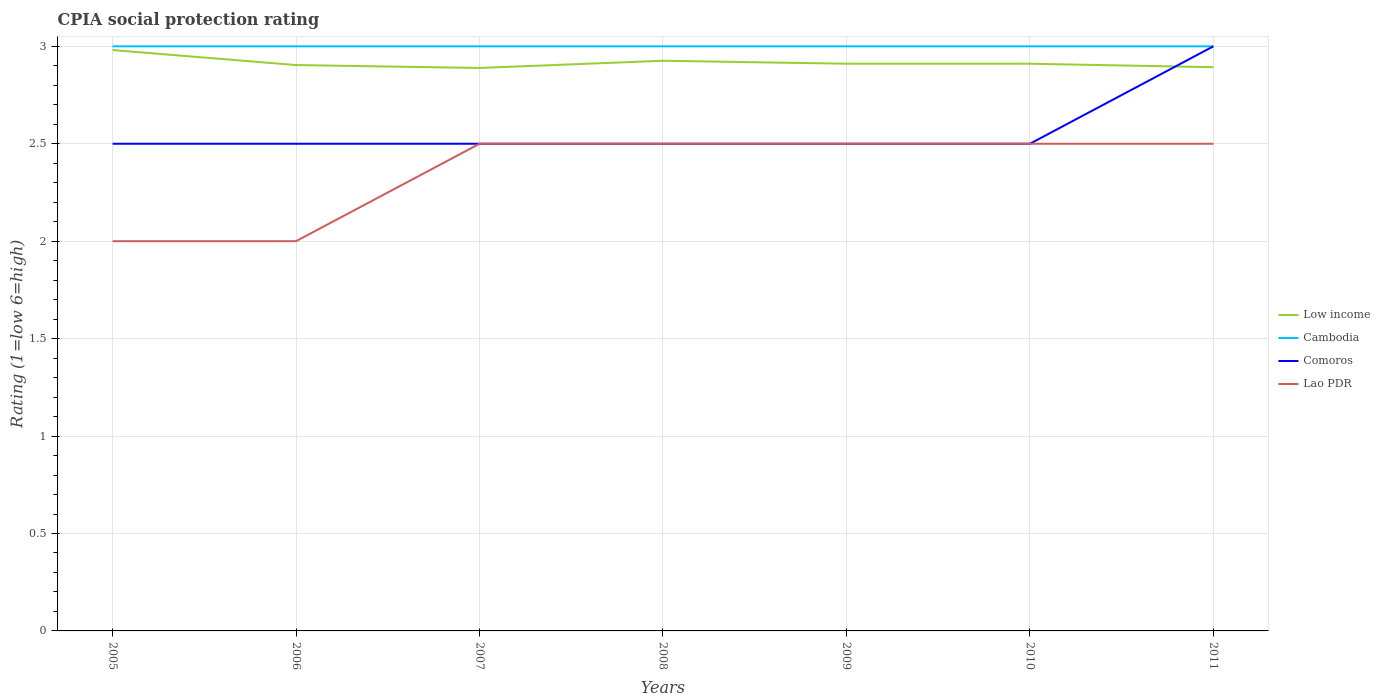Across all years, what is the maximum CPIA rating in Lao PDR?
Ensure brevity in your answer.  2. What is the total CPIA rating in Low income in the graph?
Your response must be concise. -0.04. What is the difference between the highest and the second highest CPIA rating in Lao PDR?
Your response must be concise. 0.5. What is the difference between the highest and the lowest CPIA rating in Cambodia?
Your answer should be compact. 0. What is the title of the graph?
Provide a short and direct response. CPIA social protection rating. What is the Rating (1=low 6=high) of Low income in 2005?
Make the answer very short. 2.98. What is the Rating (1=low 6=high) in Comoros in 2005?
Provide a short and direct response. 2.5. What is the Rating (1=low 6=high) of Lao PDR in 2005?
Give a very brief answer. 2. What is the Rating (1=low 6=high) of Low income in 2006?
Provide a succinct answer. 2.9. What is the Rating (1=low 6=high) in Cambodia in 2006?
Offer a very short reply. 3. What is the Rating (1=low 6=high) in Comoros in 2006?
Your response must be concise. 2.5. What is the Rating (1=low 6=high) in Low income in 2007?
Make the answer very short. 2.89. What is the Rating (1=low 6=high) of Cambodia in 2007?
Ensure brevity in your answer.  3. What is the Rating (1=low 6=high) in Low income in 2008?
Offer a terse response. 2.93. What is the Rating (1=low 6=high) in Comoros in 2008?
Offer a very short reply. 2.5. What is the Rating (1=low 6=high) in Low income in 2009?
Offer a very short reply. 2.91. What is the Rating (1=low 6=high) in Comoros in 2009?
Your answer should be compact. 2.5. What is the Rating (1=low 6=high) in Low income in 2010?
Give a very brief answer. 2.91. What is the Rating (1=low 6=high) of Cambodia in 2010?
Provide a short and direct response. 3. What is the Rating (1=low 6=high) of Comoros in 2010?
Your answer should be very brief. 2.5. What is the Rating (1=low 6=high) in Lao PDR in 2010?
Your answer should be compact. 2.5. What is the Rating (1=low 6=high) of Low income in 2011?
Provide a succinct answer. 2.89. What is the Rating (1=low 6=high) of Comoros in 2011?
Ensure brevity in your answer.  3. Across all years, what is the maximum Rating (1=low 6=high) of Low income?
Your answer should be compact. 2.98. Across all years, what is the maximum Rating (1=low 6=high) of Cambodia?
Ensure brevity in your answer.  3. Across all years, what is the maximum Rating (1=low 6=high) of Comoros?
Offer a terse response. 3. Across all years, what is the maximum Rating (1=low 6=high) of Lao PDR?
Your response must be concise. 2.5. Across all years, what is the minimum Rating (1=low 6=high) of Low income?
Keep it short and to the point. 2.89. Across all years, what is the minimum Rating (1=low 6=high) of Cambodia?
Ensure brevity in your answer.  3. Across all years, what is the minimum Rating (1=low 6=high) of Comoros?
Offer a very short reply. 2.5. What is the total Rating (1=low 6=high) of Low income in the graph?
Give a very brief answer. 20.41. What is the total Rating (1=low 6=high) in Cambodia in the graph?
Give a very brief answer. 21. What is the total Rating (1=low 6=high) in Comoros in the graph?
Offer a very short reply. 18. What is the difference between the Rating (1=low 6=high) of Low income in 2005 and that in 2006?
Make the answer very short. 0.08. What is the difference between the Rating (1=low 6=high) of Cambodia in 2005 and that in 2006?
Your response must be concise. 0. What is the difference between the Rating (1=low 6=high) in Comoros in 2005 and that in 2006?
Give a very brief answer. 0. What is the difference between the Rating (1=low 6=high) of Lao PDR in 2005 and that in 2006?
Offer a terse response. 0. What is the difference between the Rating (1=low 6=high) of Low income in 2005 and that in 2007?
Give a very brief answer. 0.09. What is the difference between the Rating (1=low 6=high) of Cambodia in 2005 and that in 2007?
Offer a terse response. 0. What is the difference between the Rating (1=low 6=high) in Low income in 2005 and that in 2008?
Provide a short and direct response. 0.05. What is the difference between the Rating (1=low 6=high) of Cambodia in 2005 and that in 2008?
Make the answer very short. 0. What is the difference between the Rating (1=low 6=high) in Comoros in 2005 and that in 2008?
Provide a short and direct response. 0. What is the difference between the Rating (1=low 6=high) of Low income in 2005 and that in 2009?
Keep it short and to the point. 0.07. What is the difference between the Rating (1=low 6=high) in Cambodia in 2005 and that in 2009?
Keep it short and to the point. 0. What is the difference between the Rating (1=low 6=high) of Lao PDR in 2005 and that in 2009?
Your answer should be compact. -0.5. What is the difference between the Rating (1=low 6=high) in Low income in 2005 and that in 2010?
Provide a succinct answer. 0.07. What is the difference between the Rating (1=low 6=high) of Comoros in 2005 and that in 2010?
Provide a succinct answer. 0. What is the difference between the Rating (1=low 6=high) of Lao PDR in 2005 and that in 2010?
Provide a succinct answer. -0.5. What is the difference between the Rating (1=low 6=high) of Low income in 2005 and that in 2011?
Give a very brief answer. 0.09. What is the difference between the Rating (1=low 6=high) of Cambodia in 2005 and that in 2011?
Offer a very short reply. 0. What is the difference between the Rating (1=low 6=high) of Comoros in 2005 and that in 2011?
Make the answer very short. -0.5. What is the difference between the Rating (1=low 6=high) of Lao PDR in 2005 and that in 2011?
Offer a terse response. -0.5. What is the difference between the Rating (1=low 6=high) of Low income in 2006 and that in 2007?
Your response must be concise. 0.01. What is the difference between the Rating (1=low 6=high) of Comoros in 2006 and that in 2007?
Your answer should be very brief. 0. What is the difference between the Rating (1=low 6=high) in Lao PDR in 2006 and that in 2007?
Your answer should be very brief. -0.5. What is the difference between the Rating (1=low 6=high) in Low income in 2006 and that in 2008?
Provide a short and direct response. -0.02. What is the difference between the Rating (1=low 6=high) in Lao PDR in 2006 and that in 2008?
Offer a terse response. -0.5. What is the difference between the Rating (1=low 6=high) of Low income in 2006 and that in 2009?
Your answer should be compact. -0.01. What is the difference between the Rating (1=low 6=high) in Low income in 2006 and that in 2010?
Your answer should be very brief. -0.01. What is the difference between the Rating (1=low 6=high) of Comoros in 2006 and that in 2010?
Your answer should be very brief. 0. What is the difference between the Rating (1=low 6=high) in Low income in 2006 and that in 2011?
Make the answer very short. 0.01. What is the difference between the Rating (1=low 6=high) of Cambodia in 2006 and that in 2011?
Offer a very short reply. 0. What is the difference between the Rating (1=low 6=high) of Low income in 2007 and that in 2008?
Keep it short and to the point. -0.04. What is the difference between the Rating (1=low 6=high) in Lao PDR in 2007 and that in 2008?
Provide a succinct answer. 0. What is the difference between the Rating (1=low 6=high) of Low income in 2007 and that in 2009?
Give a very brief answer. -0.02. What is the difference between the Rating (1=low 6=high) in Lao PDR in 2007 and that in 2009?
Ensure brevity in your answer.  0. What is the difference between the Rating (1=low 6=high) of Low income in 2007 and that in 2010?
Ensure brevity in your answer.  -0.02. What is the difference between the Rating (1=low 6=high) of Cambodia in 2007 and that in 2010?
Make the answer very short. 0. What is the difference between the Rating (1=low 6=high) of Low income in 2007 and that in 2011?
Provide a succinct answer. -0. What is the difference between the Rating (1=low 6=high) of Cambodia in 2007 and that in 2011?
Make the answer very short. 0. What is the difference between the Rating (1=low 6=high) of Comoros in 2007 and that in 2011?
Provide a short and direct response. -0.5. What is the difference between the Rating (1=low 6=high) of Low income in 2008 and that in 2009?
Provide a succinct answer. 0.02. What is the difference between the Rating (1=low 6=high) in Cambodia in 2008 and that in 2009?
Provide a succinct answer. 0. What is the difference between the Rating (1=low 6=high) in Comoros in 2008 and that in 2009?
Your response must be concise. 0. What is the difference between the Rating (1=low 6=high) of Low income in 2008 and that in 2010?
Your answer should be compact. 0.02. What is the difference between the Rating (1=low 6=high) of Cambodia in 2008 and that in 2010?
Give a very brief answer. 0. What is the difference between the Rating (1=low 6=high) of Comoros in 2008 and that in 2010?
Keep it short and to the point. 0. What is the difference between the Rating (1=low 6=high) in Lao PDR in 2008 and that in 2010?
Your response must be concise. 0. What is the difference between the Rating (1=low 6=high) of Low income in 2008 and that in 2011?
Your answer should be compact. 0.03. What is the difference between the Rating (1=low 6=high) in Lao PDR in 2009 and that in 2010?
Ensure brevity in your answer.  0. What is the difference between the Rating (1=low 6=high) in Low income in 2009 and that in 2011?
Offer a terse response. 0.02. What is the difference between the Rating (1=low 6=high) of Comoros in 2009 and that in 2011?
Offer a very short reply. -0.5. What is the difference between the Rating (1=low 6=high) in Low income in 2010 and that in 2011?
Offer a very short reply. 0.02. What is the difference between the Rating (1=low 6=high) in Comoros in 2010 and that in 2011?
Your answer should be very brief. -0.5. What is the difference between the Rating (1=low 6=high) in Low income in 2005 and the Rating (1=low 6=high) in Cambodia in 2006?
Keep it short and to the point. -0.02. What is the difference between the Rating (1=low 6=high) in Low income in 2005 and the Rating (1=low 6=high) in Comoros in 2006?
Keep it short and to the point. 0.48. What is the difference between the Rating (1=low 6=high) in Low income in 2005 and the Rating (1=low 6=high) in Lao PDR in 2006?
Your answer should be compact. 0.98. What is the difference between the Rating (1=low 6=high) in Cambodia in 2005 and the Rating (1=low 6=high) in Comoros in 2006?
Your answer should be very brief. 0.5. What is the difference between the Rating (1=low 6=high) in Cambodia in 2005 and the Rating (1=low 6=high) in Lao PDR in 2006?
Provide a succinct answer. 1. What is the difference between the Rating (1=low 6=high) in Low income in 2005 and the Rating (1=low 6=high) in Cambodia in 2007?
Provide a succinct answer. -0.02. What is the difference between the Rating (1=low 6=high) in Low income in 2005 and the Rating (1=low 6=high) in Comoros in 2007?
Provide a succinct answer. 0.48. What is the difference between the Rating (1=low 6=high) in Low income in 2005 and the Rating (1=low 6=high) in Lao PDR in 2007?
Give a very brief answer. 0.48. What is the difference between the Rating (1=low 6=high) of Low income in 2005 and the Rating (1=low 6=high) of Cambodia in 2008?
Your response must be concise. -0.02. What is the difference between the Rating (1=low 6=high) of Low income in 2005 and the Rating (1=low 6=high) of Comoros in 2008?
Keep it short and to the point. 0.48. What is the difference between the Rating (1=low 6=high) in Low income in 2005 and the Rating (1=low 6=high) in Lao PDR in 2008?
Your answer should be compact. 0.48. What is the difference between the Rating (1=low 6=high) of Low income in 2005 and the Rating (1=low 6=high) of Cambodia in 2009?
Your response must be concise. -0.02. What is the difference between the Rating (1=low 6=high) in Low income in 2005 and the Rating (1=low 6=high) in Comoros in 2009?
Keep it short and to the point. 0.48. What is the difference between the Rating (1=low 6=high) of Low income in 2005 and the Rating (1=low 6=high) of Lao PDR in 2009?
Make the answer very short. 0.48. What is the difference between the Rating (1=low 6=high) in Cambodia in 2005 and the Rating (1=low 6=high) in Comoros in 2009?
Offer a very short reply. 0.5. What is the difference between the Rating (1=low 6=high) of Comoros in 2005 and the Rating (1=low 6=high) of Lao PDR in 2009?
Offer a very short reply. 0. What is the difference between the Rating (1=low 6=high) of Low income in 2005 and the Rating (1=low 6=high) of Cambodia in 2010?
Your response must be concise. -0.02. What is the difference between the Rating (1=low 6=high) in Low income in 2005 and the Rating (1=low 6=high) in Comoros in 2010?
Your answer should be very brief. 0.48. What is the difference between the Rating (1=low 6=high) in Low income in 2005 and the Rating (1=low 6=high) in Lao PDR in 2010?
Provide a short and direct response. 0.48. What is the difference between the Rating (1=low 6=high) in Cambodia in 2005 and the Rating (1=low 6=high) in Comoros in 2010?
Offer a very short reply. 0.5. What is the difference between the Rating (1=low 6=high) of Comoros in 2005 and the Rating (1=low 6=high) of Lao PDR in 2010?
Ensure brevity in your answer.  0. What is the difference between the Rating (1=low 6=high) of Low income in 2005 and the Rating (1=low 6=high) of Cambodia in 2011?
Give a very brief answer. -0.02. What is the difference between the Rating (1=low 6=high) of Low income in 2005 and the Rating (1=low 6=high) of Comoros in 2011?
Your response must be concise. -0.02. What is the difference between the Rating (1=low 6=high) of Low income in 2005 and the Rating (1=low 6=high) of Lao PDR in 2011?
Offer a very short reply. 0.48. What is the difference between the Rating (1=low 6=high) in Cambodia in 2005 and the Rating (1=low 6=high) in Lao PDR in 2011?
Give a very brief answer. 0.5. What is the difference between the Rating (1=low 6=high) of Low income in 2006 and the Rating (1=low 6=high) of Cambodia in 2007?
Your response must be concise. -0.1. What is the difference between the Rating (1=low 6=high) in Low income in 2006 and the Rating (1=low 6=high) in Comoros in 2007?
Keep it short and to the point. 0.4. What is the difference between the Rating (1=low 6=high) in Low income in 2006 and the Rating (1=low 6=high) in Lao PDR in 2007?
Offer a very short reply. 0.4. What is the difference between the Rating (1=low 6=high) of Cambodia in 2006 and the Rating (1=low 6=high) of Comoros in 2007?
Give a very brief answer. 0.5. What is the difference between the Rating (1=low 6=high) of Low income in 2006 and the Rating (1=low 6=high) of Cambodia in 2008?
Your answer should be compact. -0.1. What is the difference between the Rating (1=low 6=high) of Low income in 2006 and the Rating (1=low 6=high) of Comoros in 2008?
Your response must be concise. 0.4. What is the difference between the Rating (1=low 6=high) of Low income in 2006 and the Rating (1=low 6=high) of Lao PDR in 2008?
Provide a succinct answer. 0.4. What is the difference between the Rating (1=low 6=high) of Cambodia in 2006 and the Rating (1=low 6=high) of Comoros in 2008?
Make the answer very short. 0.5. What is the difference between the Rating (1=low 6=high) of Comoros in 2006 and the Rating (1=low 6=high) of Lao PDR in 2008?
Make the answer very short. 0. What is the difference between the Rating (1=low 6=high) of Low income in 2006 and the Rating (1=low 6=high) of Cambodia in 2009?
Provide a succinct answer. -0.1. What is the difference between the Rating (1=low 6=high) in Low income in 2006 and the Rating (1=low 6=high) in Comoros in 2009?
Your answer should be compact. 0.4. What is the difference between the Rating (1=low 6=high) in Low income in 2006 and the Rating (1=low 6=high) in Lao PDR in 2009?
Offer a very short reply. 0.4. What is the difference between the Rating (1=low 6=high) in Comoros in 2006 and the Rating (1=low 6=high) in Lao PDR in 2009?
Provide a short and direct response. 0. What is the difference between the Rating (1=low 6=high) of Low income in 2006 and the Rating (1=low 6=high) of Cambodia in 2010?
Provide a short and direct response. -0.1. What is the difference between the Rating (1=low 6=high) of Low income in 2006 and the Rating (1=low 6=high) of Comoros in 2010?
Offer a very short reply. 0.4. What is the difference between the Rating (1=low 6=high) of Low income in 2006 and the Rating (1=low 6=high) of Lao PDR in 2010?
Your response must be concise. 0.4. What is the difference between the Rating (1=low 6=high) in Cambodia in 2006 and the Rating (1=low 6=high) in Lao PDR in 2010?
Keep it short and to the point. 0.5. What is the difference between the Rating (1=low 6=high) in Comoros in 2006 and the Rating (1=low 6=high) in Lao PDR in 2010?
Offer a very short reply. 0. What is the difference between the Rating (1=low 6=high) in Low income in 2006 and the Rating (1=low 6=high) in Cambodia in 2011?
Give a very brief answer. -0.1. What is the difference between the Rating (1=low 6=high) in Low income in 2006 and the Rating (1=low 6=high) in Comoros in 2011?
Offer a very short reply. -0.1. What is the difference between the Rating (1=low 6=high) of Low income in 2006 and the Rating (1=low 6=high) of Lao PDR in 2011?
Your response must be concise. 0.4. What is the difference between the Rating (1=low 6=high) of Cambodia in 2006 and the Rating (1=low 6=high) of Lao PDR in 2011?
Your answer should be compact. 0.5. What is the difference between the Rating (1=low 6=high) of Low income in 2007 and the Rating (1=low 6=high) of Cambodia in 2008?
Provide a succinct answer. -0.11. What is the difference between the Rating (1=low 6=high) in Low income in 2007 and the Rating (1=low 6=high) in Comoros in 2008?
Your answer should be compact. 0.39. What is the difference between the Rating (1=low 6=high) in Low income in 2007 and the Rating (1=low 6=high) in Lao PDR in 2008?
Provide a succinct answer. 0.39. What is the difference between the Rating (1=low 6=high) in Cambodia in 2007 and the Rating (1=low 6=high) in Comoros in 2008?
Your response must be concise. 0.5. What is the difference between the Rating (1=low 6=high) in Cambodia in 2007 and the Rating (1=low 6=high) in Lao PDR in 2008?
Provide a short and direct response. 0.5. What is the difference between the Rating (1=low 6=high) in Low income in 2007 and the Rating (1=low 6=high) in Cambodia in 2009?
Offer a terse response. -0.11. What is the difference between the Rating (1=low 6=high) of Low income in 2007 and the Rating (1=low 6=high) of Comoros in 2009?
Your answer should be very brief. 0.39. What is the difference between the Rating (1=low 6=high) of Low income in 2007 and the Rating (1=low 6=high) of Lao PDR in 2009?
Your answer should be compact. 0.39. What is the difference between the Rating (1=low 6=high) in Comoros in 2007 and the Rating (1=low 6=high) in Lao PDR in 2009?
Your answer should be very brief. 0. What is the difference between the Rating (1=low 6=high) of Low income in 2007 and the Rating (1=low 6=high) of Cambodia in 2010?
Your response must be concise. -0.11. What is the difference between the Rating (1=low 6=high) in Low income in 2007 and the Rating (1=low 6=high) in Comoros in 2010?
Keep it short and to the point. 0.39. What is the difference between the Rating (1=low 6=high) in Low income in 2007 and the Rating (1=low 6=high) in Lao PDR in 2010?
Offer a very short reply. 0.39. What is the difference between the Rating (1=low 6=high) of Cambodia in 2007 and the Rating (1=low 6=high) of Lao PDR in 2010?
Provide a short and direct response. 0.5. What is the difference between the Rating (1=low 6=high) of Comoros in 2007 and the Rating (1=low 6=high) of Lao PDR in 2010?
Provide a succinct answer. 0. What is the difference between the Rating (1=low 6=high) in Low income in 2007 and the Rating (1=low 6=high) in Cambodia in 2011?
Provide a short and direct response. -0.11. What is the difference between the Rating (1=low 6=high) of Low income in 2007 and the Rating (1=low 6=high) of Comoros in 2011?
Make the answer very short. -0.11. What is the difference between the Rating (1=low 6=high) of Low income in 2007 and the Rating (1=low 6=high) of Lao PDR in 2011?
Your answer should be very brief. 0.39. What is the difference between the Rating (1=low 6=high) in Cambodia in 2007 and the Rating (1=low 6=high) in Comoros in 2011?
Ensure brevity in your answer.  0. What is the difference between the Rating (1=low 6=high) in Low income in 2008 and the Rating (1=low 6=high) in Cambodia in 2009?
Offer a terse response. -0.07. What is the difference between the Rating (1=low 6=high) of Low income in 2008 and the Rating (1=low 6=high) of Comoros in 2009?
Ensure brevity in your answer.  0.43. What is the difference between the Rating (1=low 6=high) of Low income in 2008 and the Rating (1=low 6=high) of Lao PDR in 2009?
Provide a short and direct response. 0.43. What is the difference between the Rating (1=low 6=high) of Cambodia in 2008 and the Rating (1=low 6=high) of Comoros in 2009?
Provide a short and direct response. 0.5. What is the difference between the Rating (1=low 6=high) in Low income in 2008 and the Rating (1=low 6=high) in Cambodia in 2010?
Make the answer very short. -0.07. What is the difference between the Rating (1=low 6=high) in Low income in 2008 and the Rating (1=low 6=high) in Comoros in 2010?
Your response must be concise. 0.43. What is the difference between the Rating (1=low 6=high) of Low income in 2008 and the Rating (1=low 6=high) of Lao PDR in 2010?
Provide a succinct answer. 0.43. What is the difference between the Rating (1=low 6=high) in Cambodia in 2008 and the Rating (1=low 6=high) in Comoros in 2010?
Make the answer very short. 0.5. What is the difference between the Rating (1=low 6=high) in Comoros in 2008 and the Rating (1=low 6=high) in Lao PDR in 2010?
Your answer should be compact. 0. What is the difference between the Rating (1=low 6=high) in Low income in 2008 and the Rating (1=low 6=high) in Cambodia in 2011?
Your response must be concise. -0.07. What is the difference between the Rating (1=low 6=high) of Low income in 2008 and the Rating (1=low 6=high) of Comoros in 2011?
Keep it short and to the point. -0.07. What is the difference between the Rating (1=low 6=high) of Low income in 2008 and the Rating (1=low 6=high) of Lao PDR in 2011?
Provide a succinct answer. 0.43. What is the difference between the Rating (1=low 6=high) in Cambodia in 2008 and the Rating (1=low 6=high) in Lao PDR in 2011?
Provide a succinct answer. 0.5. What is the difference between the Rating (1=low 6=high) in Low income in 2009 and the Rating (1=low 6=high) in Cambodia in 2010?
Make the answer very short. -0.09. What is the difference between the Rating (1=low 6=high) of Low income in 2009 and the Rating (1=low 6=high) of Comoros in 2010?
Your response must be concise. 0.41. What is the difference between the Rating (1=low 6=high) in Low income in 2009 and the Rating (1=low 6=high) in Lao PDR in 2010?
Your answer should be very brief. 0.41. What is the difference between the Rating (1=low 6=high) in Cambodia in 2009 and the Rating (1=low 6=high) in Comoros in 2010?
Ensure brevity in your answer.  0.5. What is the difference between the Rating (1=low 6=high) of Comoros in 2009 and the Rating (1=low 6=high) of Lao PDR in 2010?
Your answer should be very brief. 0. What is the difference between the Rating (1=low 6=high) of Low income in 2009 and the Rating (1=low 6=high) of Cambodia in 2011?
Your answer should be very brief. -0.09. What is the difference between the Rating (1=low 6=high) of Low income in 2009 and the Rating (1=low 6=high) of Comoros in 2011?
Give a very brief answer. -0.09. What is the difference between the Rating (1=low 6=high) in Low income in 2009 and the Rating (1=low 6=high) in Lao PDR in 2011?
Keep it short and to the point. 0.41. What is the difference between the Rating (1=low 6=high) in Comoros in 2009 and the Rating (1=low 6=high) in Lao PDR in 2011?
Give a very brief answer. 0. What is the difference between the Rating (1=low 6=high) of Low income in 2010 and the Rating (1=low 6=high) of Cambodia in 2011?
Give a very brief answer. -0.09. What is the difference between the Rating (1=low 6=high) of Low income in 2010 and the Rating (1=low 6=high) of Comoros in 2011?
Make the answer very short. -0.09. What is the difference between the Rating (1=low 6=high) in Low income in 2010 and the Rating (1=low 6=high) in Lao PDR in 2011?
Provide a succinct answer. 0.41. What is the difference between the Rating (1=low 6=high) in Cambodia in 2010 and the Rating (1=low 6=high) in Comoros in 2011?
Give a very brief answer. 0. What is the average Rating (1=low 6=high) of Low income per year?
Keep it short and to the point. 2.92. What is the average Rating (1=low 6=high) of Cambodia per year?
Your answer should be very brief. 3. What is the average Rating (1=low 6=high) in Comoros per year?
Provide a short and direct response. 2.57. What is the average Rating (1=low 6=high) of Lao PDR per year?
Offer a terse response. 2.36. In the year 2005, what is the difference between the Rating (1=low 6=high) in Low income and Rating (1=low 6=high) in Cambodia?
Ensure brevity in your answer.  -0.02. In the year 2005, what is the difference between the Rating (1=low 6=high) of Low income and Rating (1=low 6=high) of Comoros?
Your answer should be very brief. 0.48. In the year 2005, what is the difference between the Rating (1=low 6=high) of Low income and Rating (1=low 6=high) of Lao PDR?
Your response must be concise. 0.98. In the year 2005, what is the difference between the Rating (1=low 6=high) of Cambodia and Rating (1=low 6=high) of Lao PDR?
Offer a terse response. 1. In the year 2005, what is the difference between the Rating (1=low 6=high) in Comoros and Rating (1=low 6=high) in Lao PDR?
Offer a very short reply. 0.5. In the year 2006, what is the difference between the Rating (1=low 6=high) of Low income and Rating (1=low 6=high) of Cambodia?
Ensure brevity in your answer.  -0.1. In the year 2006, what is the difference between the Rating (1=low 6=high) in Low income and Rating (1=low 6=high) in Comoros?
Offer a very short reply. 0.4. In the year 2006, what is the difference between the Rating (1=low 6=high) in Low income and Rating (1=low 6=high) in Lao PDR?
Your response must be concise. 0.9. In the year 2006, what is the difference between the Rating (1=low 6=high) in Cambodia and Rating (1=low 6=high) in Comoros?
Provide a succinct answer. 0.5. In the year 2006, what is the difference between the Rating (1=low 6=high) in Cambodia and Rating (1=low 6=high) in Lao PDR?
Give a very brief answer. 1. In the year 2006, what is the difference between the Rating (1=low 6=high) in Comoros and Rating (1=low 6=high) in Lao PDR?
Your answer should be very brief. 0.5. In the year 2007, what is the difference between the Rating (1=low 6=high) of Low income and Rating (1=low 6=high) of Cambodia?
Keep it short and to the point. -0.11. In the year 2007, what is the difference between the Rating (1=low 6=high) in Low income and Rating (1=low 6=high) in Comoros?
Give a very brief answer. 0.39. In the year 2007, what is the difference between the Rating (1=low 6=high) in Low income and Rating (1=low 6=high) in Lao PDR?
Your answer should be compact. 0.39. In the year 2007, what is the difference between the Rating (1=low 6=high) of Cambodia and Rating (1=low 6=high) of Lao PDR?
Provide a short and direct response. 0.5. In the year 2008, what is the difference between the Rating (1=low 6=high) in Low income and Rating (1=low 6=high) in Cambodia?
Your answer should be very brief. -0.07. In the year 2008, what is the difference between the Rating (1=low 6=high) of Low income and Rating (1=low 6=high) of Comoros?
Provide a succinct answer. 0.43. In the year 2008, what is the difference between the Rating (1=low 6=high) of Low income and Rating (1=low 6=high) of Lao PDR?
Give a very brief answer. 0.43. In the year 2009, what is the difference between the Rating (1=low 6=high) of Low income and Rating (1=low 6=high) of Cambodia?
Give a very brief answer. -0.09. In the year 2009, what is the difference between the Rating (1=low 6=high) of Low income and Rating (1=low 6=high) of Comoros?
Offer a very short reply. 0.41. In the year 2009, what is the difference between the Rating (1=low 6=high) of Low income and Rating (1=low 6=high) of Lao PDR?
Offer a very short reply. 0.41. In the year 2010, what is the difference between the Rating (1=low 6=high) of Low income and Rating (1=low 6=high) of Cambodia?
Offer a terse response. -0.09. In the year 2010, what is the difference between the Rating (1=low 6=high) of Low income and Rating (1=low 6=high) of Comoros?
Your answer should be compact. 0.41. In the year 2010, what is the difference between the Rating (1=low 6=high) of Low income and Rating (1=low 6=high) of Lao PDR?
Give a very brief answer. 0.41. In the year 2010, what is the difference between the Rating (1=low 6=high) in Cambodia and Rating (1=low 6=high) in Lao PDR?
Provide a short and direct response. 0.5. In the year 2011, what is the difference between the Rating (1=low 6=high) of Low income and Rating (1=low 6=high) of Cambodia?
Make the answer very short. -0.11. In the year 2011, what is the difference between the Rating (1=low 6=high) of Low income and Rating (1=low 6=high) of Comoros?
Offer a very short reply. -0.11. In the year 2011, what is the difference between the Rating (1=low 6=high) in Low income and Rating (1=low 6=high) in Lao PDR?
Keep it short and to the point. 0.39. In the year 2011, what is the difference between the Rating (1=low 6=high) of Comoros and Rating (1=low 6=high) of Lao PDR?
Provide a short and direct response. 0.5. What is the ratio of the Rating (1=low 6=high) in Low income in 2005 to that in 2006?
Provide a short and direct response. 1.03. What is the ratio of the Rating (1=low 6=high) of Cambodia in 2005 to that in 2006?
Ensure brevity in your answer.  1. What is the ratio of the Rating (1=low 6=high) of Comoros in 2005 to that in 2006?
Offer a terse response. 1. What is the ratio of the Rating (1=low 6=high) of Low income in 2005 to that in 2007?
Your answer should be very brief. 1.03. What is the ratio of the Rating (1=low 6=high) of Comoros in 2005 to that in 2007?
Offer a terse response. 1. What is the ratio of the Rating (1=low 6=high) in Lao PDR in 2005 to that in 2007?
Offer a very short reply. 0.8. What is the ratio of the Rating (1=low 6=high) in Low income in 2005 to that in 2008?
Your answer should be very brief. 1.02. What is the ratio of the Rating (1=low 6=high) in Cambodia in 2005 to that in 2008?
Your answer should be compact. 1. What is the ratio of the Rating (1=low 6=high) of Comoros in 2005 to that in 2008?
Your response must be concise. 1. What is the ratio of the Rating (1=low 6=high) in Low income in 2005 to that in 2009?
Provide a short and direct response. 1.02. What is the ratio of the Rating (1=low 6=high) of Cambodia in 2005 to that in 2009?
Your answer should be compact. 1. What is the ratio of the Rating (1=low 6=high) of Low income in 2005 to that in 2010?
Keep it short and to the point. 1.02. What is the ratio of the Rating (1=low 6=high) of Low income in 2005 to that in 2011?
Provide a short and direct response. 1.03. What is the ratio of the Rating (1=low 6=high) of Cambodia in 2005 to that in 2011?
Ensure brevity in your answer.  1. What is the ratio of the Rating (1=low 6=high) in Comoros in 2005 to that in 2011?
Offer a terse response. 0.83. What is the ratio of the Rating (1=low 6=high) of Lao PDR in 2005 to that in 2011?
Give a very brief answer. 0.8. What is the ratio of the Rating (1=low 6=high) in Low income in 2006 to that in 2007?
Provide a succinct answer. 1.01. What is the ratio of the Rating (1=low 6=high) of Comoros in 2006 to that in 2007?
Your response must be concise. 1. What is the ratio of the Rating (1=low 6=high) in Low income in 2006 to that in 2008?
Provide a succinct answer. 0.99. What is the ratio of the Rating (1=low 6=high) of Lao PDR in 2006 to that in 2008?
Provide a short and direct response. 0.8. What is the ratio of the Rating (1=low 6=high) of Comoros in 2006 to that in 2009?
Your response must be concise. 1. What is the ratio of the Rating (1=low 6=high) of Lao PDR in 2006 to that in 2009?
Your response must be concise. 0.8. What is the ratio of the Rating (1=low 6=high) of Cambodia in 2006 to that in 2010?
Provide a succinct answer. 1. What is the ratio of the Rating (1=low 6=high) in Comoros in 2006 to that in 2010?
Your response must be concise. 1. What is the ratio of the Rating (1=low 6=high) in Lao PDR in 2006 to that in 2010?
Offer a very short reply. 0.8. What is the ratio of the Rating (1=low 6=high) of Cambodia in 2006 to that in 2011?
Your response must be concise. 1. What is the ratio of the Rating (1=low 6=high) in Lao PDR in 2006 to that in 2011?
Offer a very short reply. 0.8. What is the ratio of the Rating (1=low 6=high) of Low income in 2007 to that in 2008?
Ensure brevity in your answer.  0.99. What is the ratio of the Rating (1=low 6=high) of Cambodia in 2007 to that in 2008?
Your answer should be compact. 1. What is the ratio of the Rating (1=low 6=high) in Lao PDR in 2007 to that in 2008?
Give a very brief answer. 1. What is the ratio of the Rating (1=low 6=high) of Low income in 2007 to that in 2009?
Provide a short and direct response. 0.99. What is the ratio of the Rating (1=low 6=high) in Comoros in 2007 to that in 2009?
Keep it short and to the point. 1. What is the ratio of the Rating (1=low 6=high) of Lao PDR in 2007 to that in 2009?
Ensure brevity in your answer.  1. What is the ratio of the Rating (1=low 6=high) of Comoros in 2007 to that in 2010?
Keep it short and to the point. 1. What is the ratio of the Rating (1=low 6=high) in Comoros in 2007 to that in 2011?
Your answer should be very brief. 0.83. What is the ratio of the Rating (1=low 6=high) of Lao PDR in 2007 to that in 2011?
Ensure brevity in your answer.  1. What is the ratio of the Rating (1=low 6=high) in Low income in 2008 to that in 2009?
Offer a very short reply. 1.01. What is the ratio of the Rating (1=low 6=high) of Cambodia in 2008 to that in 2009?
Offer a very short reply. 1. What is the ratio of the Rating (1=low 6=high) in Lao PDR in 2008 to that in 2010?
Your response must be concise. 1. What is the ratio of the Rating (1=low 6=high) of Low income in 2008 to that in 2011?
Ensure brevity in your answer.  1.01. What is the ratio of the Rating (1=low 6=high) in Cambodia in 2008 to that in 2011?
Offer a terse response. 1. What is the ratio of the Rating (1=low 6=high) in Comoros in 2009 to that in 2010?
Your answer should be compact. 1. What is the ratio of the Rating (1=low 6=high) in Comoros in 2009 to that in 2011?
Your answer should be very brief. 0.83. What is the ratio of the Rating (1=low 6=high) in Lao PDR in 2009 to that in 2011?
Offer a terse response. 1. What is the ratio of the Rating (1=low 6=high) of Low income in 2010 to that in 2011?
Your response must be concise. 1.01. What is the difference between the highest and the second highest Rating (1=low 6=high) of Low income?
Provide a short and direct response. 0.05. What is the difference between the highest and the second highest Rating (1=low 6=high) of Cambodia?
Ensure brevity in your answer.  0. What is the difference between the highest and the lowest Rating (1=low 6=high) of Low income?
Give a very brief answer. 0.09. What is the difference between the highest and the lowest Rating (1=low 6=high) in Cambodia?
Give a very brief answer. 0. 